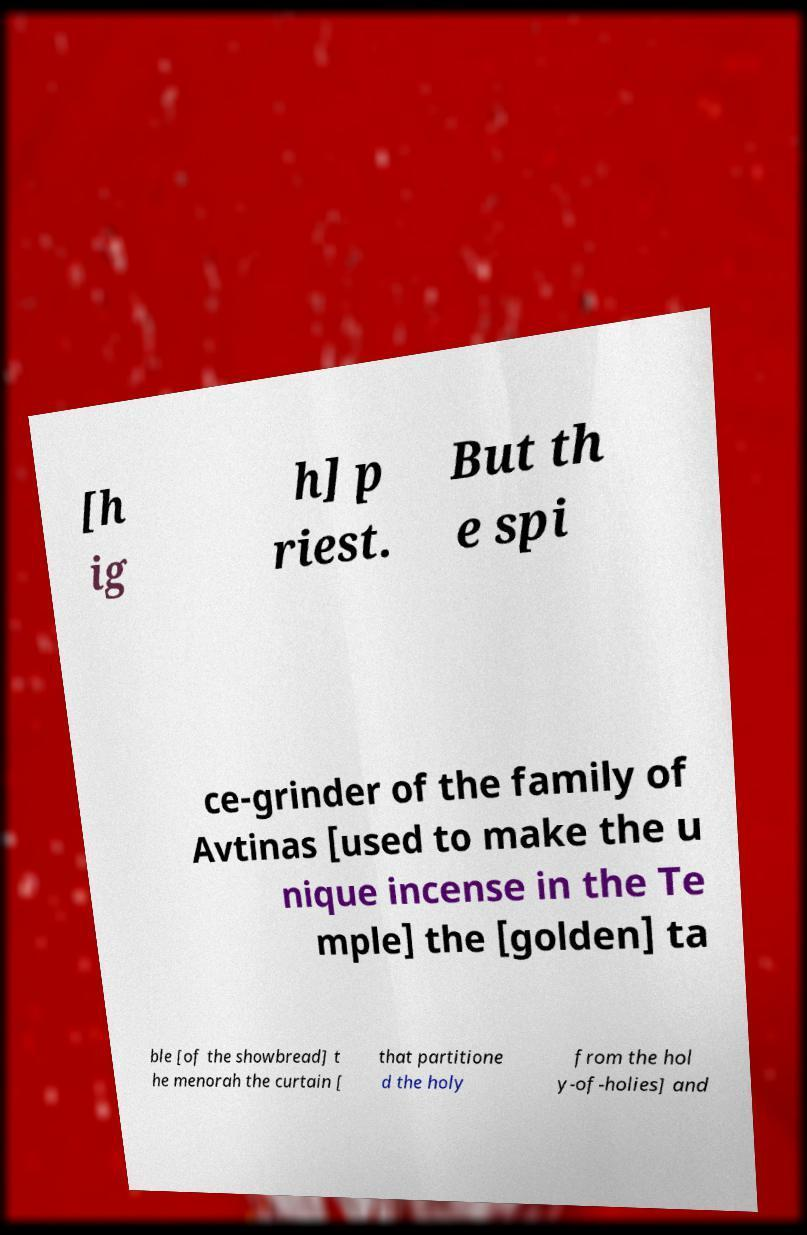Could you extract and type out the text from this image? [h ig h] p riest. But th e spi ce-grinder of the family of Avtinas [used to make the u nique incense in the Te mple] the [golden] ta ble [of the showbread] t he menorah the curtain [ that partitione d the holy from the hol y-of-holies] and 